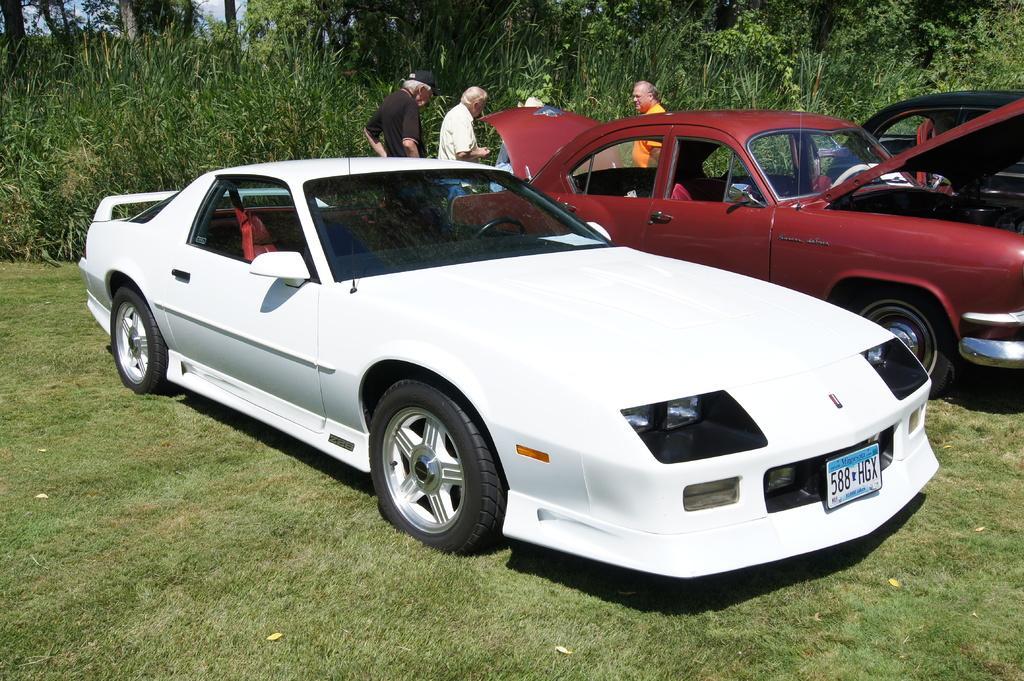Describe this image in one or two sentences. This picture shows few cars parked and we see a car open trunk and bonnet and we see few people standing and we see plants and trees and grass on the ground. 